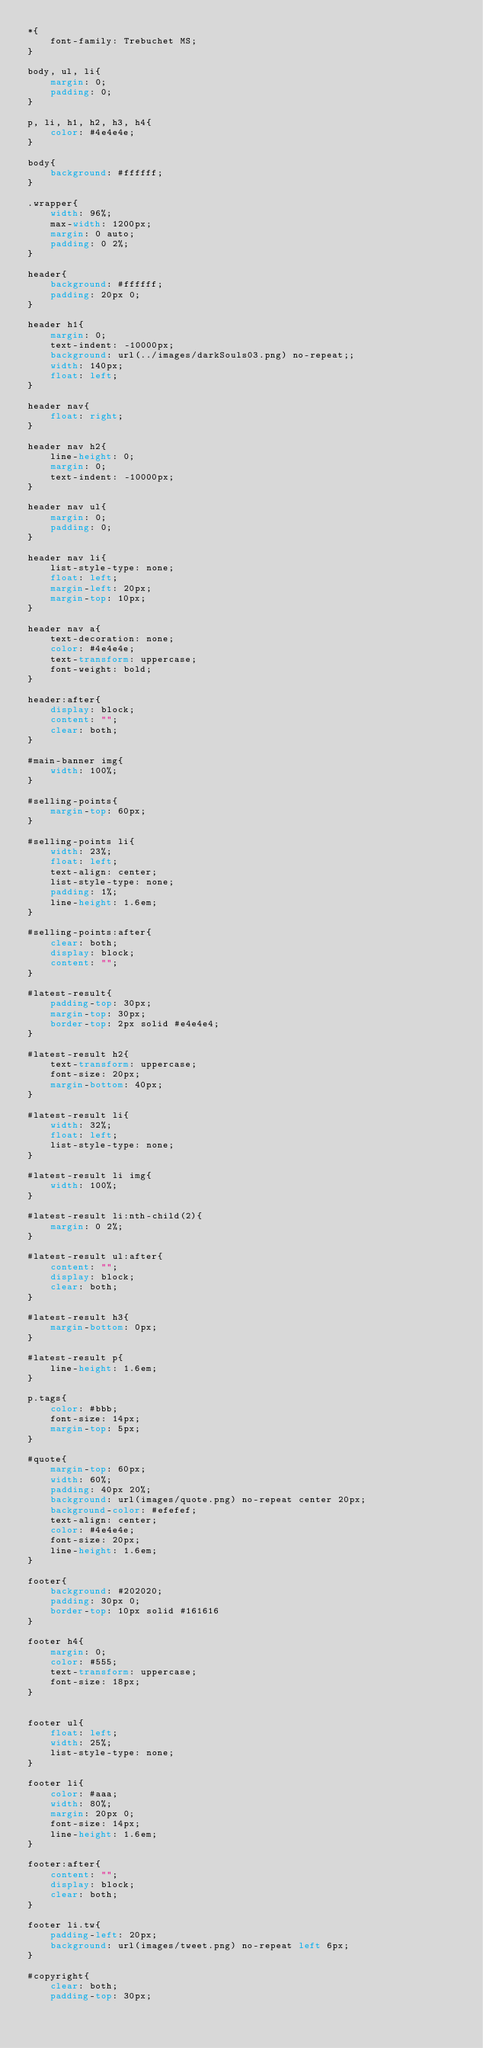Convert code to text. <code><loc_0><loc_0><loc_500><loc_500><_CSS_>*{
    font-family: Trebuchet MS;
}

body, ul, li{
    margin: 0;
    padding: 0;
}

p, li, h1, h2, h3, h4{
    color: #4e4e4e;
}

body{
    background: #ffffff;
}

.wrapper{
    width: 96%;
    max-width: 1200px;
    margin: 0 auto;
    padding: 0 2%;
}

header{
    background: #ffffff;
    padding: 20px 0;
}

header h1{
    margin: 0;
    text-indent: -10000px;
    background: url(../images/darkSouls03.png) no-repeat;;
    width: 140px;
    float: left;
}

header nav{
    float: right;
}

header nav h2{
    line-height: 0;
    margin: 0;
    text-indent: -10000px;
}

header nav ul{
    margin: 0;
    padding: 0;
}

header nav li{
    list-style-type: none;
    float: left;
    margin-left: 20px;
    margin-top: 10px;
}

header nav a{
    text-decoration: none;
    color: #4e4e4e;
    text-transform: uppercase;
    font-weight: bold;
}

header:after{
    display: block;
    content: "";
    clear: both;
}

#main-banner img{
    width: 100%;
}

#selling-points{
    margin-top: 60px;
}

#selling-points li{
    width: 23%;
    float: left;
    text-align: center;
    list-style-type: none;
    padding: 1%;
    line-height: 1.6em;
}

#selling-points:after{
    clear: both;
    display: block;
    content: "";
}

#latest-result{
    padding-top: 30px;
    margin-top: 30px;
    border-top: 2px solid #e4e4e4;
}

#latest-result h2{
    text-transform: uppercase;
    font-size: 20px;
    margin-bottom: 40px;
}

#latest-result li{
    width: 32%;
    float: left;
    list-style-type: none;
}

#latest-result li img{
    width: 100%;
}

#latest-result li:nth-child(2){
    margin: 0 2%;
}

#latest-result ul:after{
    content: "";
    display: block;
    clear: both;
}

#latest-result h3{
    margin-bottom: 0px;
}

#latest-result p{
    line-height: 1.6em;
}

p.tags{
    color: #bbb;
    font-size: 14px;
    margin-top: 5px;
}

#quote{
    margin-top: 60px;
    width: 60%;
    padding: 40px 20%;
    background: url(images/quote.png) no-repeat center 20px;
    background-color: #efefef;
    text-align: center;
    color: #4e4e4e;
    font-size: 20px;
    line-height: 1.6em; 
}

footer{
    background: #202020;
    padding: 30px 0;
    border-top: 10px solid #161616
}

footer h4{
    margin: 0;
    color: #555;
    text-transform: uppercase;
    font-size: 18px;
}


footer ul{
    float: left;
    width: 25%;
    list-style-type: none;
}

footer li{
    color: #aaa;
    width: 80%;
    margin: 20px 0;
    font-size: 14px;
    line-height: 1.6em;
} 

footer:after{
    content: "";
    display: block;
    clear: both;
}

footer li.tw{
    padding-left: 20px;
    background: url(images/tweet.png) no-repeat left 6px;
}

#copyright{
    clear: both;
    padding-top: 30px;</code> 